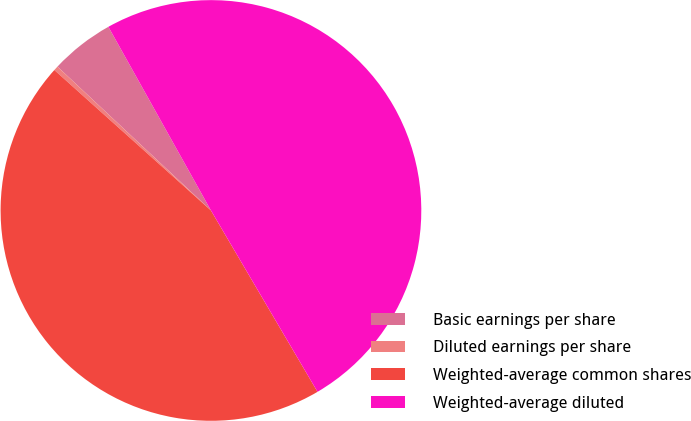Convert chart. <chart><loc_0><loc_0><loc_500><loc_500><pie_chart><fcel>Basic earnings per share<fcel>Diluted earnings per share<fcel>Weighted-average common shares<fcel>Weighted-average diluted<nl><fcel>4.91%<fcel>0.35%<fcel>45.09%<fcel>49.65%<nl></chart> 